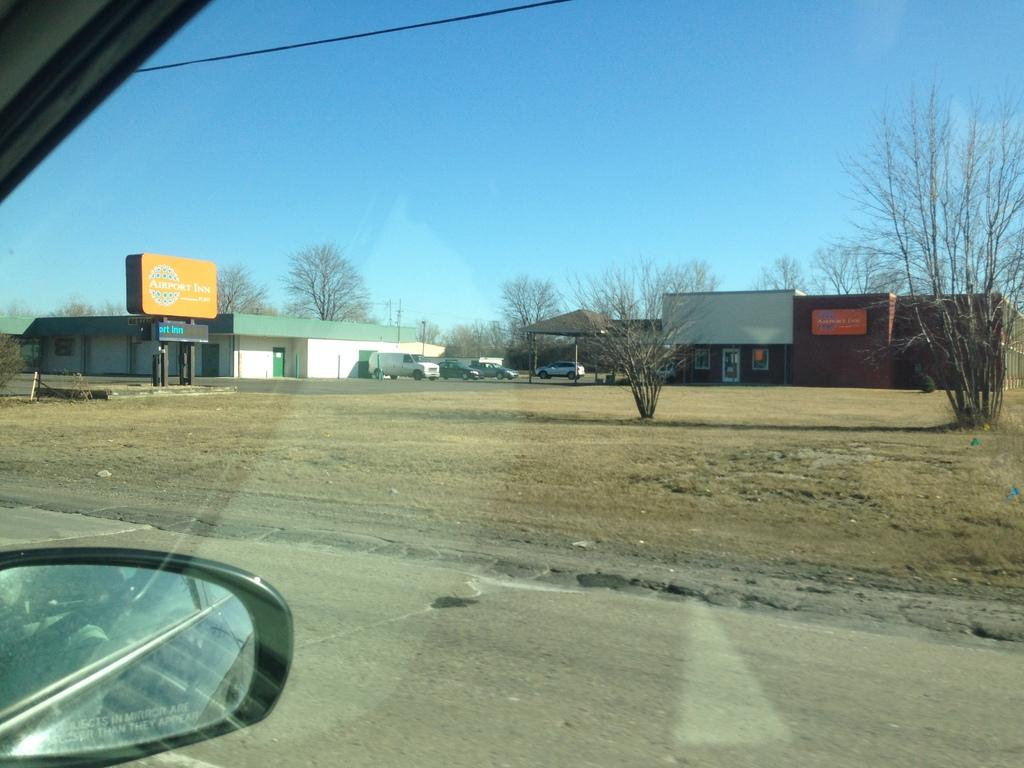What types of vehicles can be seen in the image? There are many vehicles in the image. What natural elements are present in the image? There are trees and dry grass in the image. What man-made structures can be seen in the image? There is a shed and a poster in the image. What type of infrastructure is visible in the image? There is a road and electric wires in the image. What part of the natural environment is visible in the image? The sky is visible in the image. What type of spot does the minister visit in the image? There is no minister or spot present in the image. What type of industry is depicted in the image? There is no industry depicted in the image. 